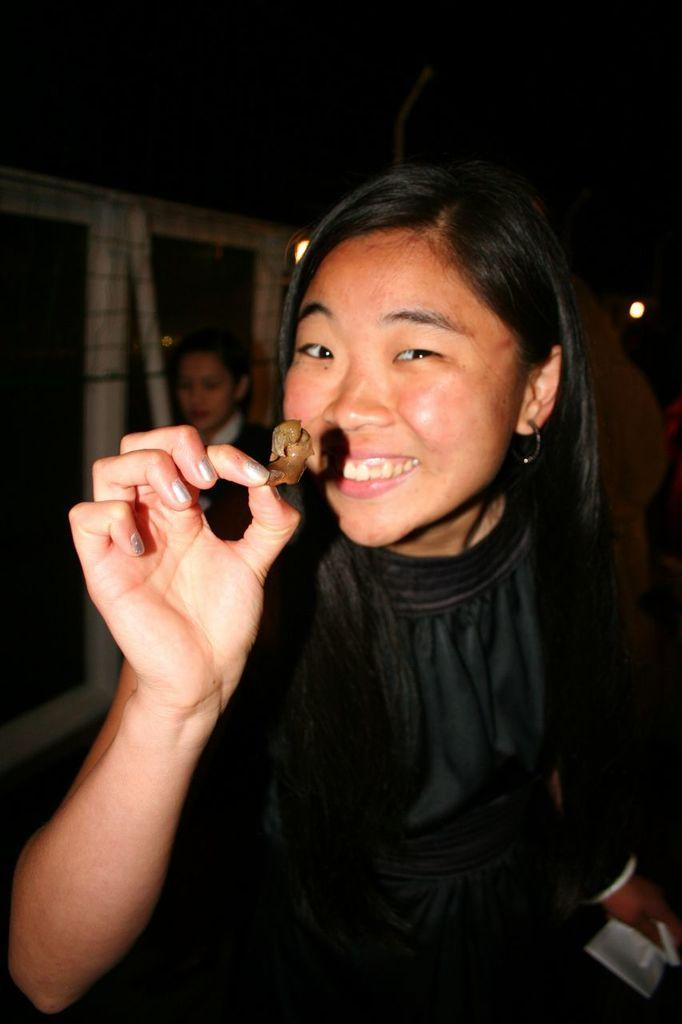What is the woman in the image holding? The woman is holding food in the image. What can be seen behind the woman? There is a wall visible in the image. Are there any openings in the wall? Yes, there are windows in the image. Can you describe the other person in the image? There is another woman standing in the background of the image. How many mice are visible on the woman's elbow in the image? There are no mice visible on the woman's elbow in the image. 